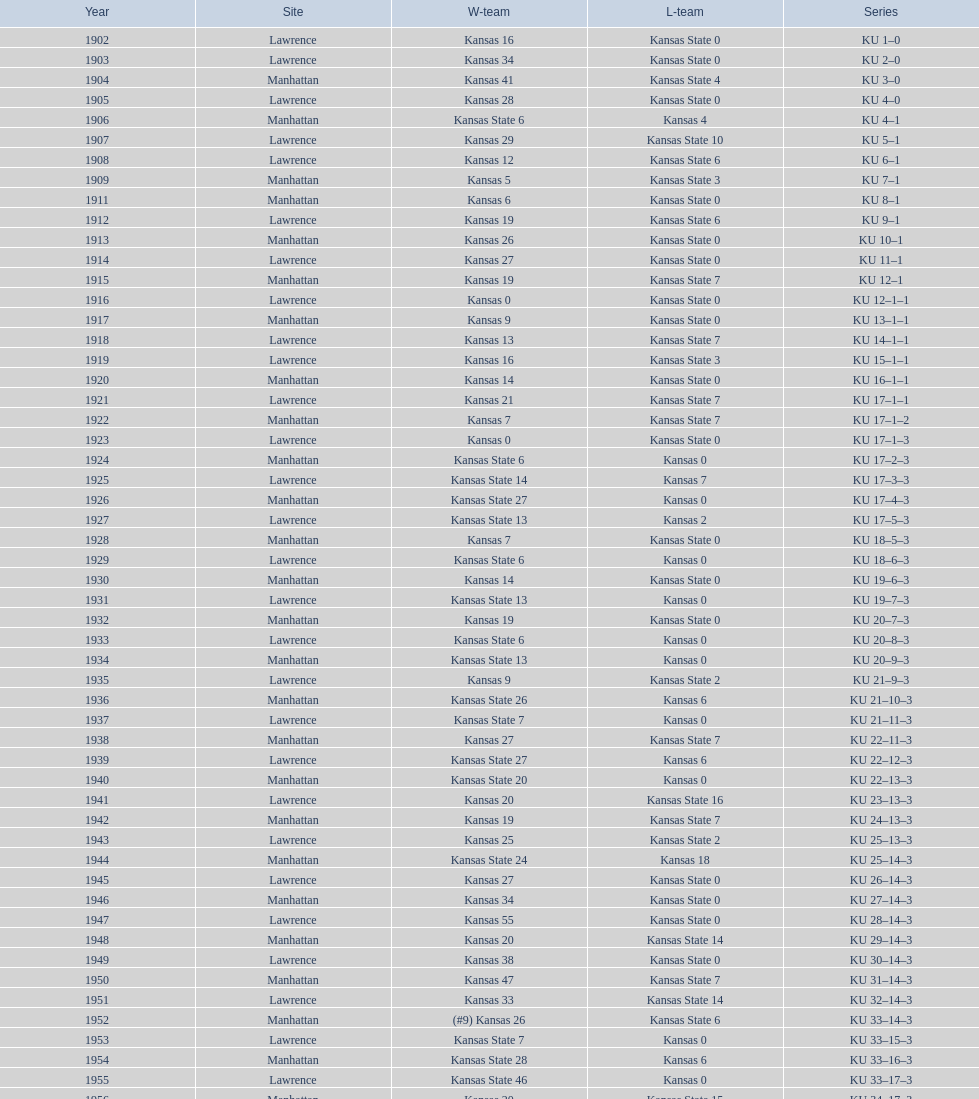How many times did kansas beat kansas state before 1910? 7. 